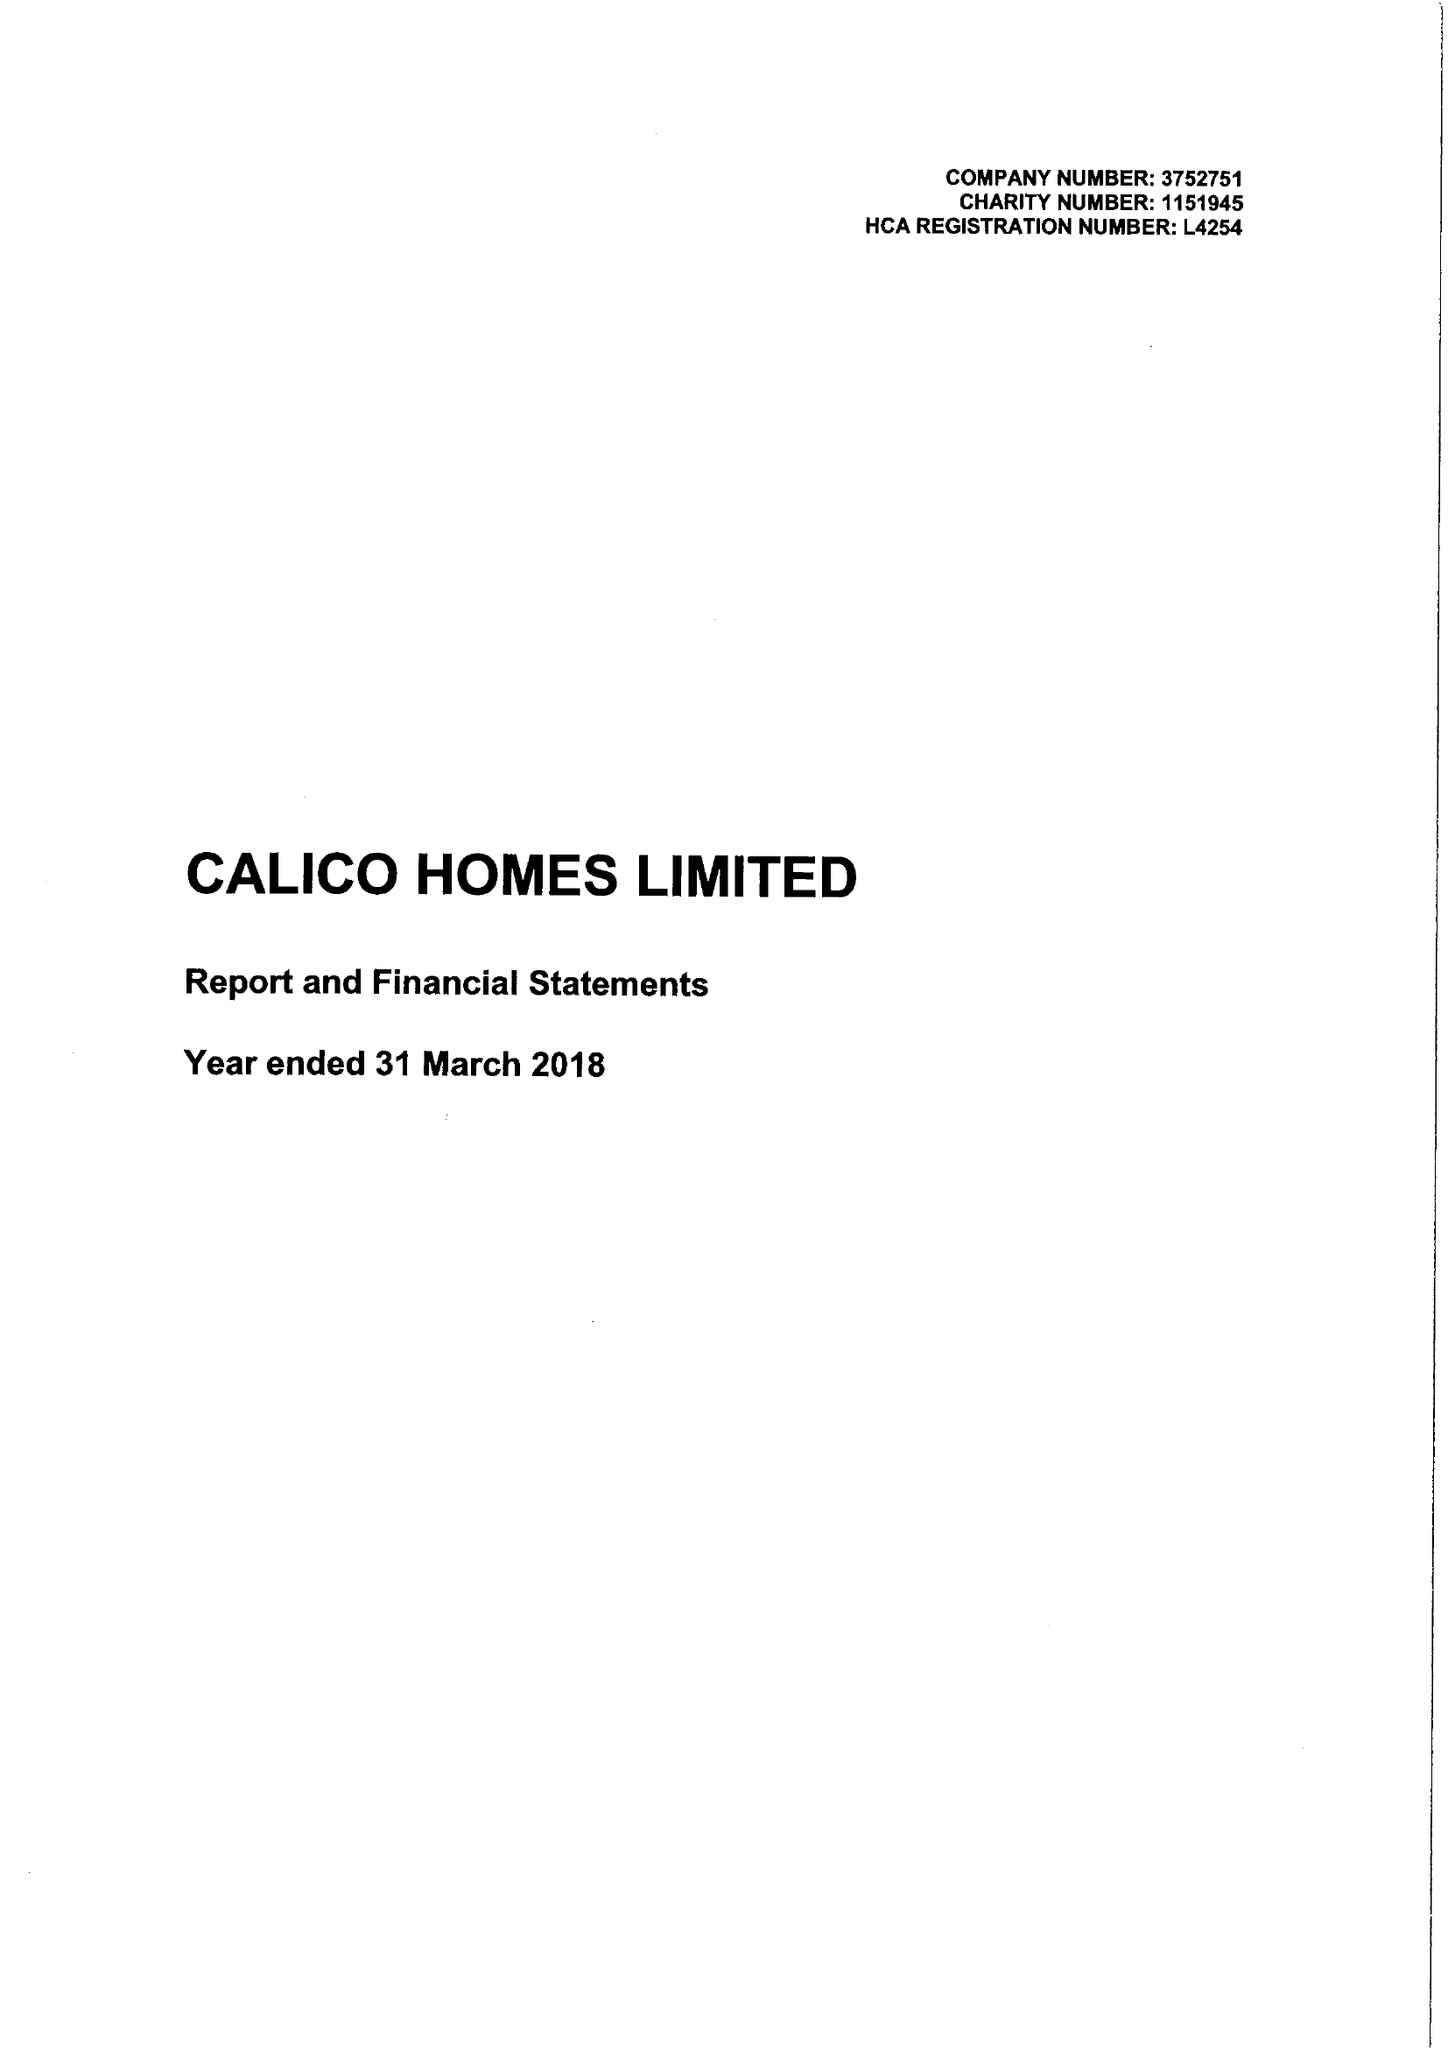What is the value for the spending_annually_in_british_pounds?
Answer the question using a single word or phrase. 20708000.00 